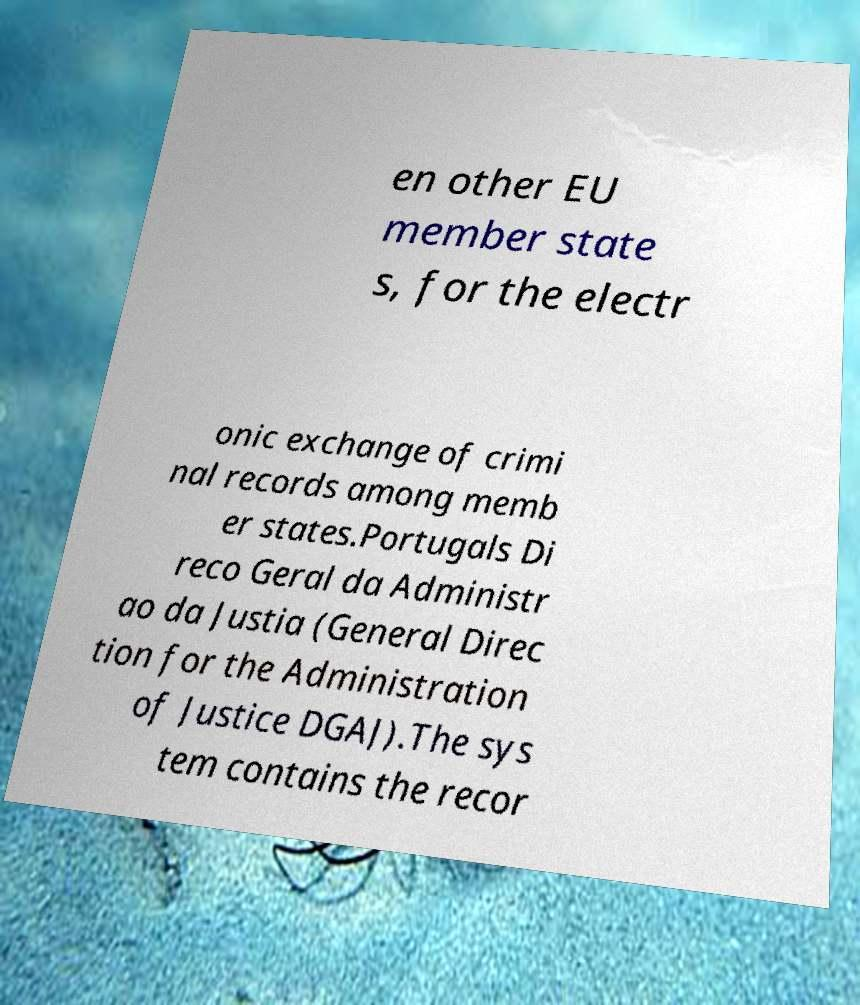Can you accurately transcribe the text from the provided image for me? en other EU member state s, for the electr onic exchange of crimi nal records among memb er states.Portugals Di reco Geral da Administr ao da Justia (General Direc tion for the Administration of Justice DGAJ).The sys tem contains the recor 